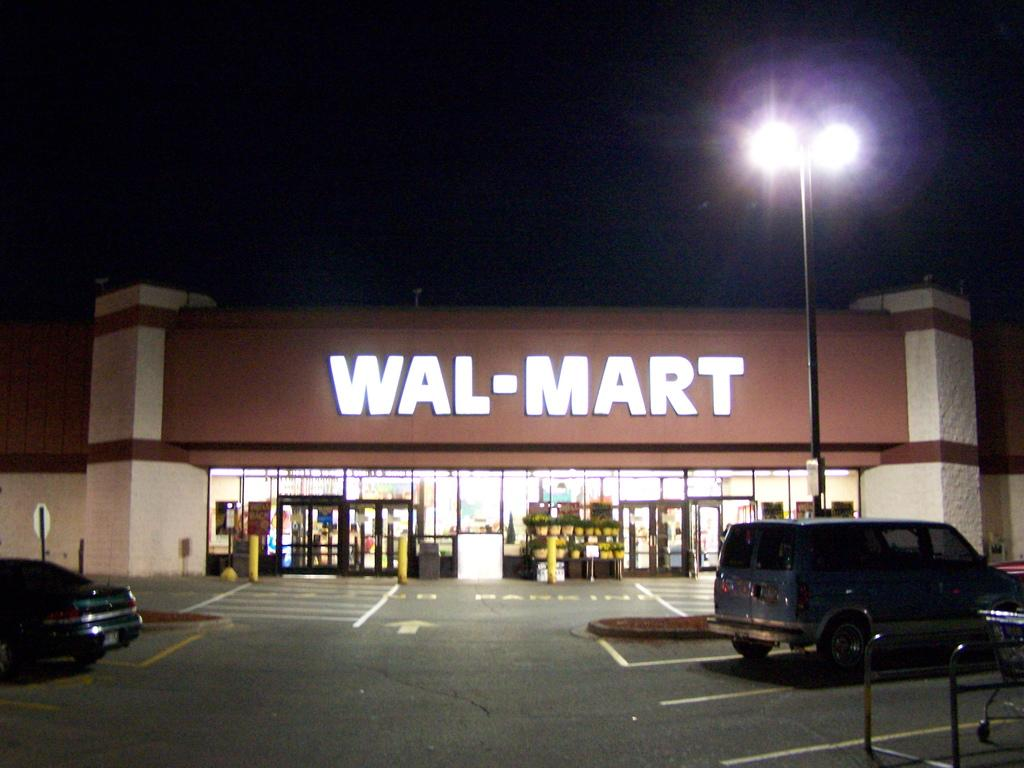<image>
Summarize the visual content of the image. A Walmart store at night time with some cars at the parking lot. 